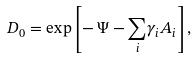Convert formula to latex. <formula><loc_0><loc_0><loc_500><loc_500>D _ { 0 } = \exp \left [ - \, \Psi - \underset { i } { \sum } \gamma _ { i } A _ { i } \right ] ,</formula> 